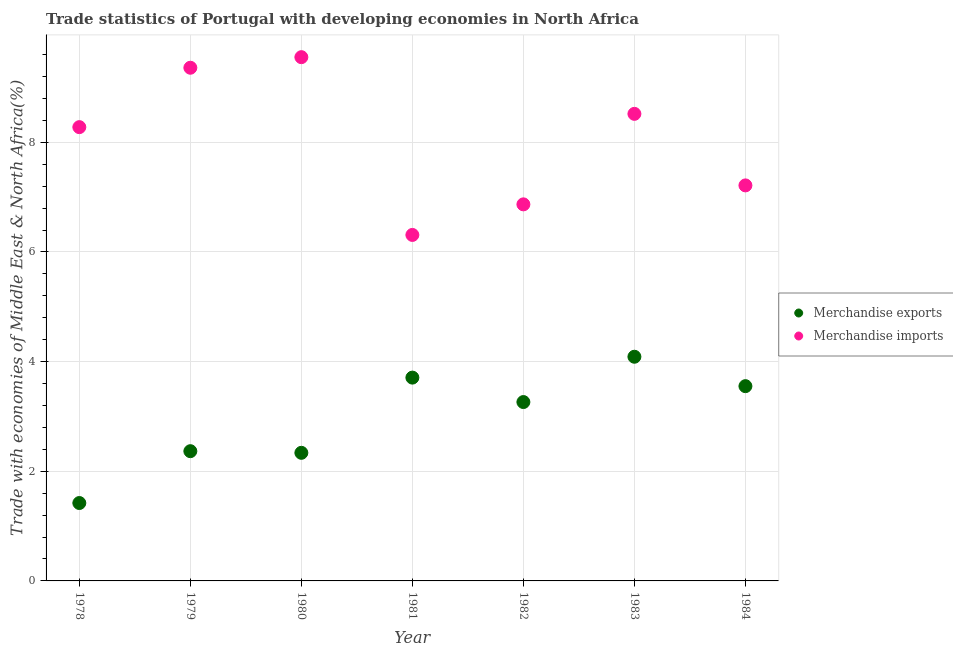Is the number of dotlines equal to the number of legend labels?
Your answer should be very brief. Yes. What is the merchandise exports in 1981?
Give a very brief answer. 3.71. Across all years, what is the maximum merchandise imports?
Make the answer very short. 9.55. Across all years, what is the minimum merchandise imports?
Provide a short and direct response. 6.31. In which year was the merchandise exports minimum?
Give a very brief answer. 1978. What is the total merchandise imports in the graph?
Make the answer very short. 56.11. What is the difference between the merchandise imports in 1978 and that in 1983?
Give a very brief answer. -0.24. What is the difference between the merchandise imports in 1983 and the merchandise exports in 1980?
Your answer should be compact. 6.18. What is the average merchandise imports per year?
Your answer should be very brief. 8.02. In the year 1982, what is the difference between the merchandise imports and merchandise exports?
Make the answer very short. 3.61. What is the ratio of the merchandise exports in 1981 to that in 1984?
Your answer should be very brief. 1.04. Is the difference between the merchandise exports in 1978 and 1979 greater than the difference between the merchandise imports in 1978 and 1979?
Make the answer very short. Yes. What is the difference between the highest and the second highest merchandise exports?
Your answer should be very brief. 0.38. What is the difference between the highest and the lowest merchandise imports?
Provide a succinct answer. 3.24. In how many years, is the merchandise exports greater than the average merchandise exports taken over all years?
Keep it short and to the point. 4. Is the merchandise exports strictly greater than the merchandise imports over the years?
Provide a short and direct response. No. Is the merchandise exports strictly less than the merchandise imports over the years?
Make the answer very short. Yes. How many dotlines are there?
Provide a succinct answer. 2. Does the graph contain grids?
Make the answer very short. Yes. How are the legend labels stacked?
Make the answer very short. Vertical. What is the title of the graph?
Ensure brevity in your answer.  Trade statistics of Portugal with developing economies in North Africa. What is the label or title of the Y-axis?
Give a very brief answer. Trade with economies of Middle East & North Africa(%). What is the Trade with economies of Middle East & North Africa(%) of Merchandise exports in 1978?
Offer a terse response. 1.42. What is the Trade with economies of Middle East & North Africa(%) of Merchandise imports in 1978?
Your response must be concise. 8.28. What is the Trade with economies of Middle East & North Africa(%) of Merchandise exports in 1979?
Keep it short and to the point. 2.37. What is the Trade with economies of Middle East & North Africa(%) of Merchandise imports in 1979?
Provide a short and direct response. 9.36. What is the Trade with economies of Middle East & North Africa(%) of Merchandise exports in 1980?
Offer a very short reply. 2.34. What is the Trade with economies of Middle East & North Africa(%) of Merchandise imports in 1980?
Provide a short and direct response. 9.55. What is the Trade with economies of Middle East & North Africa(%) in Merchandise exports in 1981?
Your answer should be very brief. 3.71. What is the Trade with economies of Middle East & North Africa(%) in Merchandise imports in 1981?
Your answer should be compact. 6.31. What is the Trade with economies of Middle East & North Africa(%) of Merchandise exports in 1982?
Ensure brevity in your answer.  3.26. What is the Trade with economies of Middle East & North Africa(%) of Merchandise imports in 1982?
Offer a terse response. 6.87. What is the Trade with economies of Middle East & North Africa(%) of Merchandise exports in 1983?
Provide a succinct answer. 4.09. What is the Trade with economies of Middle East & North Africa(%) of Merchandise imports in 1983?
Provide a succinct answer. 8.52. What is the Trade with economies of Middle East & North Africa(%) in Merchandise exports in 1984?
Offer a very short reply. 3.55. What is the Trade with economies of Middle East & North Africa(%) in Merchandise imports in 1984?
Your response must be concise. 7.21. Across all years, what is the maximum Trade with economies of Middle East & North Africa(%) in Merchandise exports?
Make the answer very short. 4.09. Across all years, what is the maximum Trade with economies of Middle East & North Africa(%) of Merchandise imports?
Offer a terse response. 9.55. Across all years, what is the minimum Trade with economies of Middle East & North Africa(%) in Merchandise exports?
Offer a terse response. 1.42. Across all years, what is the minimum Trade with economies of Middle East & North Africa(%) in Merchandise imports?
Provide a succinct answer. 6.31. What is the total Trade with economies of Middle East & North Africa(%) in Merchandise exports in the graph?
Give a very brief answer. 20.74. What is the total Trade with economies of Middle East & North Africa(%) of Merchandise imports in the graph?
Your answer should be very brief. 56.11. What is the difference between the Trade with economies of Middle East & North Africa(%) in Merchandise exports in 1978 and that in 1979?
Provide a succinct answer. -0.95. What is the difference between the Trade with economies of Middle East & North Africa(%) of Merchandise imports in 1978 and that in 1979?
Your answer should be compact. -1.08. What is the difference between the Trade with economies of Middle East & North Africa(%) in Merchandise exports in 1978 and that in 1980?
Offer a very short reply. -0.92. What is the difference between the Trade with economies of Middle East & North Africa(%) in Merchandise imports in 1978 and that in 1980?
Make the answer very short. -1.28. What is the difference between the Trade with economies of Middle East & North Africa(%) in Merchandise exports in 1978 and that in 1981?
Offer a very short reply. -2.29. What is the difference between the Trade with economies of Middle East & North Africa(%) of Merchandise imports in 1978 and that in 1981?
Your answer should be compact. 1.97. What is the difference between the Trade with economies of Middle East & North Africa(%) of Merchandise exports in 1978 and that in 1982?
Give a very brief answer. -1.84. What is the difference between the Trade with economies of Middle East & North Africa(%) of Merchandise imports in 1978 and that in 1982?
Provide a succinct answer. 1.41. What is the difference between the Trade with economies of Middle East & North Africa(%) in Merchandise exports in 1978 and that in 1983?
Give a very brief answer. -2.67. What is the difference between the Trade with economies of Middle East & North Africa(%) in Merchandise imports in 1978 and that in 1983?
Offer a terse response. -0.24. What is the difference between the Trade with economies of Middle East & North Africa(%) of Merchandise exports in 1978 and that in 1984?
Your answer should be compact. -2.13. What is the difference between the Trade with economies of Middle East & North Africa(%) in Merchandise imports in 1978 and that in 1984?
Provide a short and direct response. 1.06. What is the difference between the Trade with economies of Middle East & North Africa(%) in Merchandise imports in 1979 and that in 1980?
Provide a short and direct response. -0.19. What is the difference between the Trade with economies of Middle East & North Africa(%) of Merchandise exports in 1979 and that in 1981?
Your response must be concise. -1.34. What is the difference between the Trade with economies of Middle East & North Africa(%) in Merchandise imports in 1979 and that in 1981?
Your answer should be compact. 3.05. What is the difference between the Trade with economies of Middle East & North Africa(%) of Merchandise exports in 1979 and that in 1982?
Your response must be concise. -0.9. What is the difference between the Trade with economies of Middle East & North Africa(%) in Merchandise imports in 1979 and that in 1982?
Your answer should be very brief. 2.49. What is the difference between the Trade with economies of Middle East & North Africa(%) in Merchandise exports in 1979 and that in 1983?
Give a very brief answer. -1.72. What is the difference between the Trade with economies of Middle East & North Africa(%) of Merchandise imports in 1979 and that in 1983?
Your response must be concise. 0.84. What is the difference between the Trade with economies of Middle East & North Africa(%) in Merchandise exports in 1979 and that in 1984?
Your response must be concise. -1.19. What is the difference between the Trade with economies of Middle East & North Africa(%) of Merchandise imports in 1979 and that in 1984?
Your answer should be very brief. 2.15. What is the difference between the Trade with economies of Middle East & North Africa(%) of Merchandise exports in 1980 and that in 1981?
Provide a short and direct response. -1.37. What is the difference between the Trade with economies of Middle East & North Africa(%) in Merchandise imports in 1980 and that in 1981?
Your answer should be compact. 3.24. What is the difference between the Trade with economies of Middle East & North Africa(%) of Merchandise exports in 1980 and that in 1982?
Your answer should be very brief. -0.93. What is the difference between the Trade with economies of Middle East & North Africa(%) of Merchandise imports in 1980 and that in 1982?
Offer a very short reply. 2.68. What is the difference between the Trade with economies of Middle East & North Africa(%) of Merchandise exports in 1980 and that in 1983?
Your response must be concise. -1.75. What is the difference between the Trade with economies of Middle East & North Africa(%) in Merchandise imports in 1980 and that in 1983?
Give a very brief answer. 1.03. What is the difference between the Trade with economies of Middle East & North Africa(%) in Merchandise exports in 1980 and that in 1984?
Ensure brevity in your answer.  -1.22. What is the difference between the Trade with economies of Middle East & North Africa(%) of Merchandise imports in 1980 and that in 1984?
Give a very brief answer. 2.34. What is the difference between the Trade with economies of Middle East & North Africa(%) in Merchandise exports in 1981 and that in 1982?
Offer a terse response. 0.45. What is the difference between the Trade with economies of Middle East & North Africa(%) of Merchandise imports in 1981 and that in 1982?
Make the answer very short. -0.56. What is the difference between the Trade with economies of Middle East & North Africa(%) in Merchandise exports in 1981 and that in 1983?
Offer a terse response. -0.38. What is the difference between the Trade with economies of Middle East & North Africa(%) of Merchandise imports in 1981 and that in 1983?
Ensure brevity in your answer.  -2.21. What is the difference between the Trade with economies of Middle East & North Africa(%) of Merchandise exports in 1981 and that in 1984?
Your answer should be compact. 0.16. What is the difference between the Trade with economies of Middle East & North Africa(%) in Merchandise imports in 1981 and that in 1984?
Give a very brief answer. -0.9. What is the difference between the Trade with economies of Middle East & North Africa(%) in Merchandise exports in 1982 and that in 1983?
Provide a short and direct response. -0.83. What is the difference between the Trade with economies of Middle East & North Africa(%) in Merchandise imports in 1982 and that in 1983?
Offer a very short reply. -1.65. What is the difference between the Trade with economies of Middle East & North Africa(%) of Merchandise exports in 1982 and that in 1984?
Your answer should be compact. -0.29. What is the difference between the Trade with economies of Middle East & North Africa(%) in Merchandise imports in 1982 and that in 1984?
Make the answer very short. -0.35. What is the difference between the Trade with economies of Middle East & North Africa(%) in Merchandise exports in 1983 and that in 1984?
Provide a short and direct response. 0.54. What is the difference between the Trade with economies of Middle East & North Africa(%) in Merchandise imports in 1983 and that in 1984?
Provide a succinct answer. 1.3. What is the difference between the Trade with economies of Middle East & North Africa(%) in Merchandise exports in 1978 and the Trade with economies of Middle East & North Africa(%) in Merchandise imports in 1979?
Provide a short and direct response. -7.94. What is the difference between the Trade with economies of Middle East & North Africa(%) of Merchandise exports in 1978 and the Trade with economies of Middle East & North Africa(%) of Merchandise imports in 1980?
Offer a very short reply. -8.13. What is the difference between the Trade with economies of Middle East & North Africa(%) in Merchandise exports in 1978 and the Trade with economies of Middle East & North Africa(%) in Merchandise imports in 1981?
Keep it short and to the point. -4.89. What is the difference between the Trade with economies of Middle East & North Africa(%) in Merchandise exports in 1978 and the Trade with economies of Middle East & North Africa(%) in Merchandise imports in 1982?
Provide a succinct answer. -5.45. What is the difference between the Trade with economies of Middle East & North Africa(%) of Merchandise exports in 1978 and the Trade with economies of Middle East & North Africa(%) of Merchandise imports in 1983?
Ensure brevity in your answer.  -7.1. What is the difference between the Trade with economies of Middle East & North Africa(%) in Merchandise exports in 1978 and the Trade with economies of Middle East & North Africa(%) in Merchandise imports in 1984?
Offer a very short reply. -5.79. What is the difference between the Trade with economies of Middle East & North Africa(%) of Merchandise exports in 1979 and the Trade with economies of Middle East & North Africa(%) of Merchandise imports in 1980?
Ensure brevity in your answer.  -7.19. What is the difference between the Trade with economies of Middle East & North Africa(%) of Merchandise exports in 1979 and the Trade with economies of Middle East & North Africa(%) of Merchandise imports in 1981?
Your answer should be compact. -3.94. What is the difference between the Trade with economies of Middle East & North Africa(%) of Merchandise exports in 1979 and the Trade with economies of Middle East & North Africa(%) of Merchandise imports in 1982?
Ensure brevity in your answer.  -4.5. What is the difference between the Trade with economies of Middle East & North Africa(%) of Merchandise exports in 1979 and the Trade with economies of Middle East & North Africa(%) of Merchandise imports in 1983?
Make the answer very short. -6.15. What is the difference between the Trade with economies of Middle East & North Africa(%) in Merchandise exports in 1979 and the Trade with economies of Middle East & North Africa(%) in Merchandise imports in 1984?
Your answer should be compact. -4.85. What is the difference between the Trade with economies of Middle East & North Africa(%) of Merchandise exports in 1980 and the Trade with economies of Middle East & North Africa(%) of Merchandise imports in 1981?
Offer a terse response. -3.97. What is the difference between the Trade with economies of Middle East & North Africa(%) in Merchandise exports in 1980 and the Trade with economies of Middle East & North Africa(%) in Merchandise imports in 1982?
Keep it short and to the point. -4.53. What is the difference between the Trade with economies of Middle East & North Africa(%) of Merchandise exports in 1980 and the Trade with economies of Middle East & North Africa(%) of Merchandise imports in 1983?
Your answer should be very brief. -6.18. What is the difference between the Trade with economies of Middle East & North Africa(%) in Merchandise exports in 1980 and the Trade with economies of Middle East & North Africa(%) in Merchandise imports in 1984?
Offer a very short reply. -4.88. What is the difference between the Trade with economies of Middle East & North Africa(%) of Merchandise exports in 1981 and the Trade with economies of Middle East & North Africa(%) of Merchandise imports in 1982?
Your response must be concise. -3.16. What is the difference between the Trade with economies of Middle East & North Africa(%) of Merchandise exports in 1981 and the Trade with economies of Middle East & North Africa(%) of Merchandise imports in 1983?
Provide a succinct answer. -4.81. What is the difference between the Trade with economies of Middle East & North Africa(%) in Merchandise exports in 1981 and the Trade with economies of Middle East & North Africa(%) in Merchandise imports in 1984?
Keep it short and to the point. -3.51. What is the difference between the Trade with economies of Middle East & North Africa(%) of Merchandise exports in 1982 and the Trade with economies of Middle East & North Africa(%) of Merchandise imports in 1983?
Provide a short and direct response. -5.26. What is the difference between the Trade with economies of Middle East & North Africa(%) of Merchandise exports in 1982 and the Trade with economies of Middle East & North Africa(%) of Merchandise imports in 1984?
Keep it short and to the point. -3.95. What is the difference between the Trade with economies of Middle East & North Africa(%) of Merchandise exports in 1983 and the Trade with economies of Middle East & North Africa(%) of Merchandise imports in 1984?
Offer a very short reply. -3.13. What is the average Trade with economies of Middle East & North Africa(%) of Merchandise exports per year?
Provide a succinct answer. 2.96. What is the average Trade with economies of Middle East & North Africa(%) of Merchandise imports per year?
Keep it short and to the point. 8.02. In the year 1978, what is the difference between the Trade with economies of Middle East & North Africa(%) in Merchandise exports and Trade with economies of Middle East & North Africa(%) in Merchandise imports?
Provide a short and direct response. -6.86. In the year 1979, what is the difference between the Trade with economies of Middle East & North Africa(%) in Merchandise exports and Trade with economies of Middle East & North Africa(%) in Merchandise imports?
Provide a short and direct response. -6.99. In the year 1980, what is the difference between the Trade with economies of Middle East & North Africa(%) of Merchandise exports and Trade with economies of Middle East & North Africa(%) of Merchandise imports?
Your answer should be very brief. -7.22. In the year 1981, what is the difference between the Trade with economies of Middle East & North Africa(%) of Merchandise exports and Trade with economies of Middle East & North Africa(%) of Merchandise imports?
Offer a very short reply. -2.6. In the year 1982, what is the difference between the Trade with economies of Middle East & North Africa(%) in Merchandise exports and Trade with economies of Middle East & North Africa(%) in Merchandise imports?
Give a very brief answer. -3.61. In the year 1983, what is the difference between the Trade with economies of Middle East & North Africa(%) of Merchandise exports and Trade with economies of Middle East & North Africa(%) of Merchandise imports?
Offer a very short reply. -4.43. In the year 1984, what is the difference between the Trade with economies of Middle East & North Africa(%) in Merchandise exports and Trade with economies of Middle East & North Africa(%) in Merchandise imports?
Give a very brief answer. -3.66. What is the ratio of the Trade with economies of Middle East & North Africa(%) in Merchandise exports in 1978 to that in 1979?
Make the answer very short. 0.6. What is the ratio of the Trade with economies of Middle East & North Africa(%) in Merchandise imports in 1978 to that in 1979?
Your answer should be very brief. 0.88. What is the ratio of the Trade with economies of Middle East & North Africa(%) in Merchandise exports in 1978 to that in 1980?
Keep it short and to the point. 0.61. What is the ratio of the Trade with economies of Middle East & North Africa(%) in Merchandise imports in 1978 to that in 1980?
Offer a terse response. 0.87. What is the ratio of the Trade with economies of Middle East & North Africa(%) of Merchandise exports in 1978 to that in 1981?
Provide a succinct answer. 0.38. What is the ratio of the Trade with economies of Middle East & North Africa(%) in Merchandise imports in 1978 to that in 1981?
Offer a very short reply. 1.31. What is the ratio of the Trade with economies of Middle East & North Africa(%) of Merchandise exports in 1978 to that in 1982?
Provide a short and direct response. 0.44. What is the ratio of the Trade with economies of Middle East & North Africa(%) in Merchandise imports in 1978 to that in 1982?
Provide a short and direct response. 1.21. What is the ratio of the Trade with economies of Middle East & North Africa(%) of Merchandise exports in 1978 to that in 1983?
Offer a terse response. 0.35. What is the ratio of the Trade with economies of Middle East & North Africa(%) in Merchandise imports in 1978 to that in 1983?
Provide a short and direct response. 0.97. What is the ratio of the Trade with economies of Middle East & North Africa(%) in Merchandise exports in 1978 to that in 1984?
Make the answer very short. 0.4. What is the ratio of the Trade with economies of Middle East & North Africa(%) in Merchandise imports in 1978 to that in 1984?
Offer a terse response. 1.15. What is the ratio of the Trade with economies of Middle East & North Africa(%) in Merchandise exports in 1979 to that in 1980?
Your answer should be compact. 1.01. What is the ratio of the Trade with economies of Middle East & North Africa(%) of Merchandise imports in 1979 to that in 1980?
Offer a terse response. 0.98. What is the ratio of the Trade with economies of Middle East & North Africa(%) of Merchandise exports in 1979 to that in 1981?
Keep it short and to the point. 0.64. What is the ratio of the Trade with economies of Middle East & North Africa(%) of Merchandise imports in 1979 to that in 1981?
Your answer should be very brief. 1.48. What is the ratio of the Trade with economies of Middle East & North Africa(%) of Merchandise exports in 1979 to that in 1982?
Give a very brief answer. 0.73. What is the ratio of the Trade with economies of Middle East & North Africa(%) of Merchandise imports in 1979 to that in 1982?
Your answer should be very brief. 1.36. What is the ratio of the Trade with economies of Middle East & North Africa(%) of Merchandise exports in 1979 to that in 1983?
Your answer should be very brief. 0.58. What is the ratio of the Trade with economies of Middle East & North Africa(%) in Merchandise imports in 1979 to that in 1983?
Your answer should be very brief. 1.1. What is the ratio of the Trade with economies of Middle East & North Africa(%) in Merchandise exports in 1979 to that in 1984?
Offer a terse response. 0.67. What is the ratio of the Trade with economies of Middle East & North Africa(%) in Merchandise imports in 1979 to that in 1984?
Provide a short and direct response. 1.3. What is the ratio of the Trade with economies of Middle East & North Africa(%) of Merchandise exports in 1980 to that in 1981?
Your answer should be very brief. 0.63. What is the ratio of the Trade with economies of Middle East & North Africa(%) of Merchandise imports in 1980 to that in 1981?
Provide a succinct answer. 1.51. What is the ratio of the Trade with economies of Middle East & North Africa(%) in Merchandise exports in 1980 to that in 1982?
Your answer should be very brief. 0.72. What is the ratio of the Trade with economies of Middle East & North Africa(%) in Merchandise imports in 1980 to that in 1982?
Give a very brief answer. 1.39. What is the ratio of the Trade with economies of Middle East & North Africa(%) of Merchandise exports in 1980 to that in 1983?
Your answer should be very brief. 0.57. What is the ratio of the Trade with economies of Middle East & North Africa(%) in Merchandise imports in 1980 to that in 1983?
Your answer should be compact. 1.12. What is the ratio of the Trade with economies of Middle East & North Africa(%) in Merchandise exports in 1980 to that in 1984?
Make the answer very short. 0.66. What is the ratio of the Trade with economies of Middle East & North Africa(%) in Merchandise imports in 1980 to that in 1984?
Provide a succinct answer. 1.32. What is the ratio of the Trade with economies of Middle East & North Africa(%) of Merchandise exports in 1981 to that in 1982?
Your answer should be compact. 1.14. What is the ratio of the Trade with economies of Middle East & North Africa(%) in Merchandise imports in 1981 to that in 1982?
Your response must be concise. 0.92. What is the ratio of the Trade with economies of Middle East & North Africa(%) in Merchandise exports in 1981 to that in 1983?
Your response must be concise. 0.91. What is the ratio of the Trade with economies of Middle East & North Africa(%) of Merchandise imports in 1981 to that in 1983?
Offer a terse response. 0.74. What is the ratio of the Trade with economies of Middle East & North Africa(%) of Merchandise exports in 1981 to that in 1984?
Your answer should be very brief. 1.04. What is the ratio of the Trade with economies of Middle East & North Africa(%) in Merchandise imports in 1981 to that in 1984?
Offer a terse response. 0.87. What is the ratio of the Trade with economies of Middle East & North Africa(%) in Merchandise exports in 1982 to that in 1983?
Offer a terse response. 0.8. What is the ratio of the Trade with economies of Middle East & North Africa(%) of Merchandise imports in 1982 to that in 1983?
Provide a succinct answer. 0.81. What is the ratio of the Trade with economies of Middle East & North Africa(%) of Merchandise exports in 1982 to that in 1984?
Ensure brevity in your answer.  0.92. What is the ratio of the Trade with economies of Middle East & North Africa(%) in Merchandise imports in 1982 to that in 1984?
Your answer should be very brief. 0.95. What is the ratio of the Trade with economies of Middle East & North Africa(%) of Merchandise exports in 1983 to that in 1984?
Ensure brevity in your answer.  1.15. What is the ratio of the Trade with economies of Middle East & North Africa(%) of Merchandise imports in 1983 to that in 1984?
Keep it short and to the point. 1.18. What is the difference between the highest and the second highest Trade with economies of Middle East & North Africa(%) in Merchandise exports?
Your answer should be compact. 0.38. What is the difference between the highest and the second highest Trade with economies of Middle East & North Africa(%) in Merchandise imports?
Your response must be concise. 0.19. What is the difference between the highest and the lowest Trade with economies of Middle East & North Africa(%) in Merchandise exports?
Your response must be concise. 2.67. What is the difference between the highest and the lowest Trade with economies of Middle East & North Africa(%) in Merchandise imports?
Your answer should be compact. 3.24. 